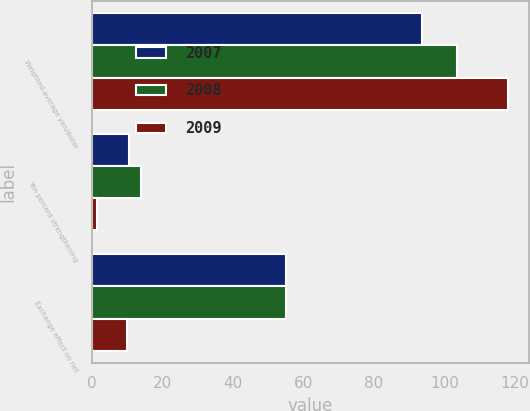Convert chart. <chart><loc_0><loc_0><loc_500><loc_500><stacked_bar_chart><ecel><fcel>Weighted-average yen/dollar<fcel>Yen percent strengthening<fcel>Exchange effect on net<nl><fcel>2007<fcel>93.49<fcel>10.7<fcel>55<nl><fcel>2008<fcel>103.46<fcel>14<fcel>55<nl><fcel>2009<fcel>117.93<fcel>1.4<fcel>10<nl></chart> 